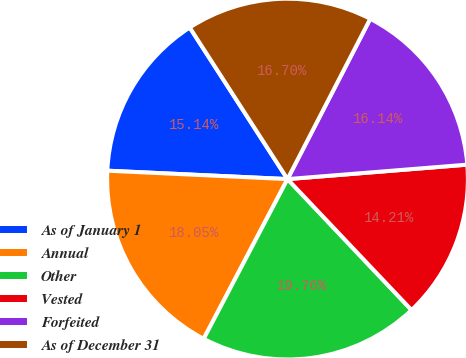Convert chart to OTSL. <chart><loc_0><loc_0><loc_500><loc_500><pie_chart><fcel>As of January 1<fcel>Annual<fcel>Other<fcel>Vested<fcel>Forfeited<fcel>As of December 31<nl><fcel>15.14%<fcel>18.05%<fcel>19.76%<fcel>14.21%<fcel>16.14%<fcel>16.7%<nl></chart> 